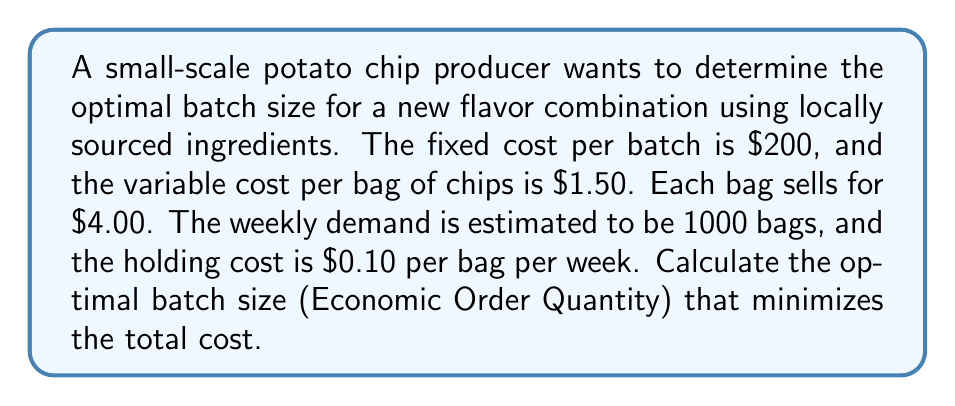Solve this math problem. To find the optimal batch size, we'll use the Economic Order Quantity (EOQ) formula:

$$EOQ = \sqrt{\frac{2DS}{H}}$$

Where:
$D$ = Annual demand
$S$ = Setup cost per order
$H$ = Holding cost per unit per year

Step 1: Calculate the annual demand (D)
Weekly demand = 1000 bags
Annual demand = 1000 * 52 weeks = 52,000 bags

Step 2: Determine the setup cost per order (S)
The fixed cost per batch is $200, so S = $200

Step 3: Calculate the holding cost per unit per year (H)
Weekly holding cost = $0.10 per bag
Annual holding cost = $0.10 * 52 weeks = $5.20 per bag per year

Step 4: Apply the EOQ formula
$$EOQ = \sqrt{\frac{2 * 52,000 * 200}{5.20}}$$
$$EOQ = \sqrt{\frac{20,800,000}{5.20}}$$
$$EOQ = \sqrt{4,000,000}$$
$$EOQ = 2,000 \text{ bags}$$

Therefore, the optimal batch size is 2,000 bags of chips.

To verify this is cost-effective:

Total annual cost = Setup cost + Holding cost
$$TC = \frac{D}{Q}S + \frac{Q}{2}H$$

Where Q is the batch size (EOQ)

$$TC = \frac{52,000}{2,000} * 200 + \frac{2,000}{2} * 5.20$$
$$TC = 5,200 + 5,200 = 10,400$$

This shows that the total annual cost for ordering and holding inventory is $10,400 when producing in batches of 2,000 bags.
Answer: The optimal batch size (Economic Order Quantity) is 2,000 bags of chips. 